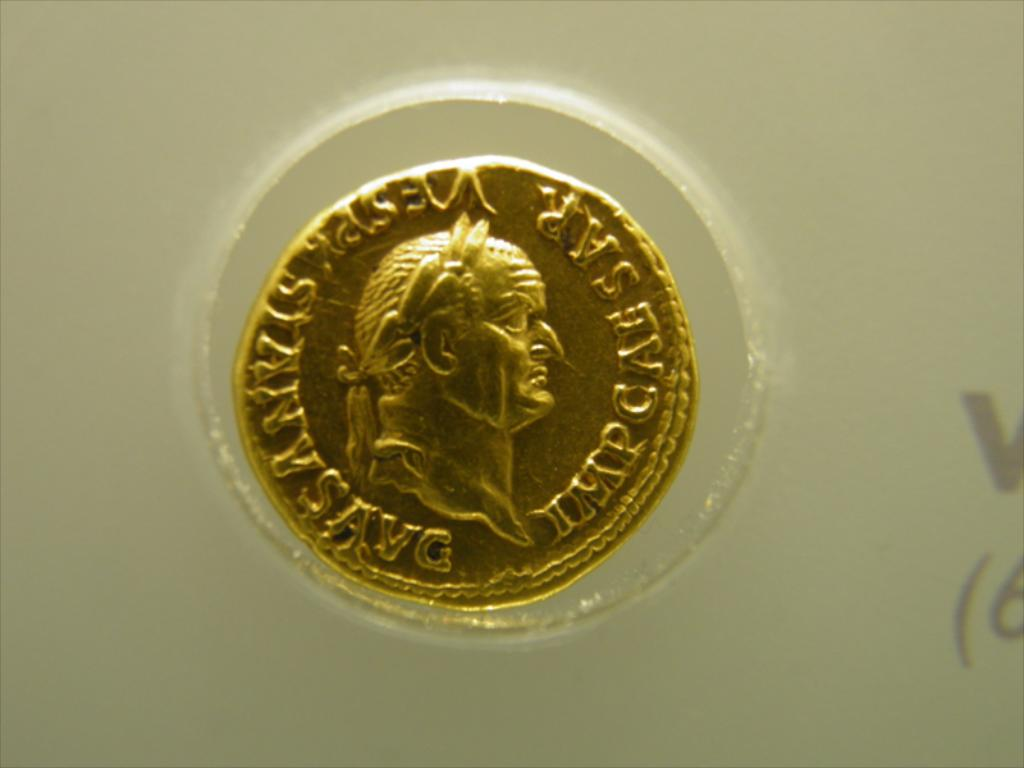Provide a one-sentence caption for the provided image. The image displays a vintage gold coin, encased in protective material, featuring a relief portrait of a prominent figure and inscribed with the abbreviation 'SAR', potentially linked to historical or monetary significance. 